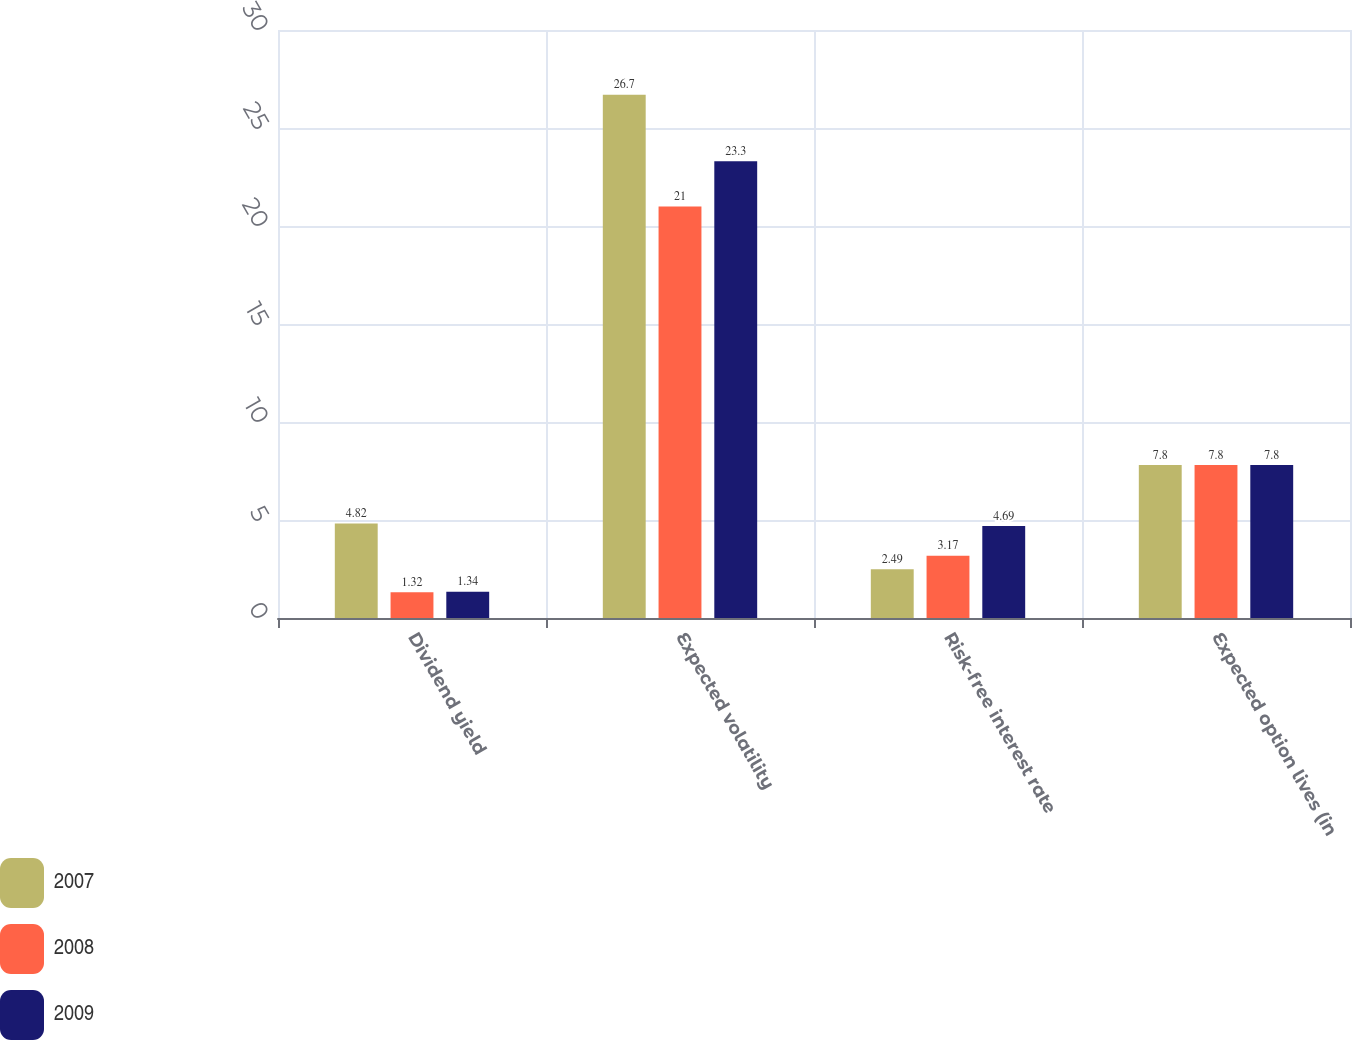Convert chart to OTSL. <chart><loc_0><loc_0><loc_500><loc_500><stacked_bar_chart><ecel><fcel>Dividend yield<fcel>Expected volatility<fcel>Risk-free interest rate<fcel>Expected option lives (in<nl><fcel>2007<fcel>4.82<fcel>26.7<fcel>2.49<fcel>7.8<nl><fcel>2008<fcel>1.32<fcel>21<fcel>3.17<fcel>7.8<nl><fcel>2009<fcel>1.34<fcel>23.3<fcel>4.69<fcel>7.8<nl></chart> 